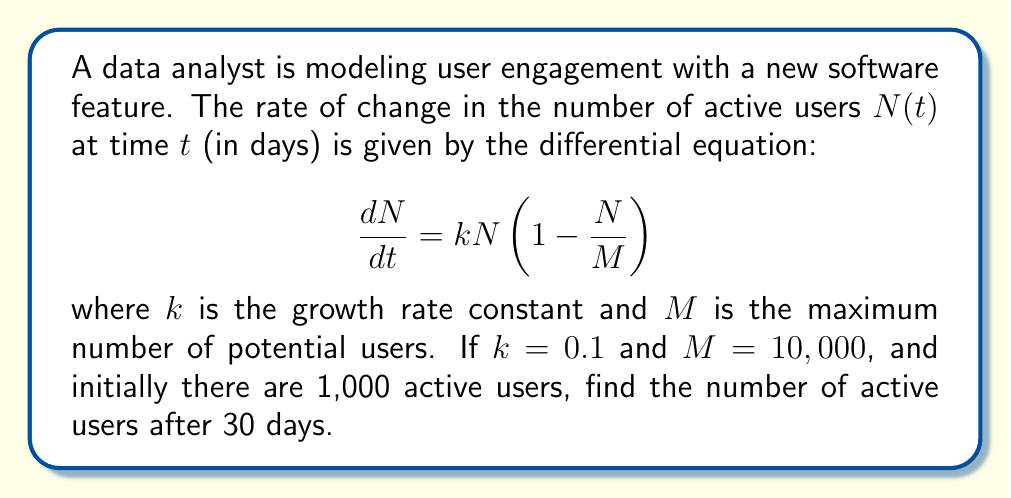Could you help me with this problem? To solve this problem, we need to use the logistic growth model, which is described by the given differential equation. Let's approach this step-by-step:

1) The general solution to the logistic growth equation is:

   $$N(t) = \frac{M}{1 + (\frac{M}{N_0} - 1)e^{-kt}}$$

   where $N_0$ is the initial number of users.

2) We're given:
   - $k = 0.1$
   - $M = 10,000$
   - $N_0 = 1,000$
   - $t = 30$

3) Let's substitute these values into the equation:

   $$N(30) = \frac{10,000}{1 + (\frac{10,000}{1,000} - 1)e^{-0.1 \cdot 30}}$$

4) Simplify:
   $$N(30) = \frac{10,000}{1 + 9e^{-3}}$$

5) Calculate $e^{-3}$:
   $$e^{-3} \approx 0.0498$$

6) Substitute this value:
   $$N(30) = \frac{10,000}{1 + 9 \cdot 0.0498} = \frac{10,000}{1.4482}$$

7) Calculate the final result:
   $$N(30) \approx 6,905.81$$

Therefore, after 30 days, there will be approximately 6,906 active users (rounding to the nearest whole number).
Answer: 6,906 active users 